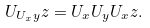<formula> <loc_0><loc_0><loc_500><loc_500>U _ { U _ { x } y } z = U _ { x } U _ { y } U _ { x } z .</formula> 